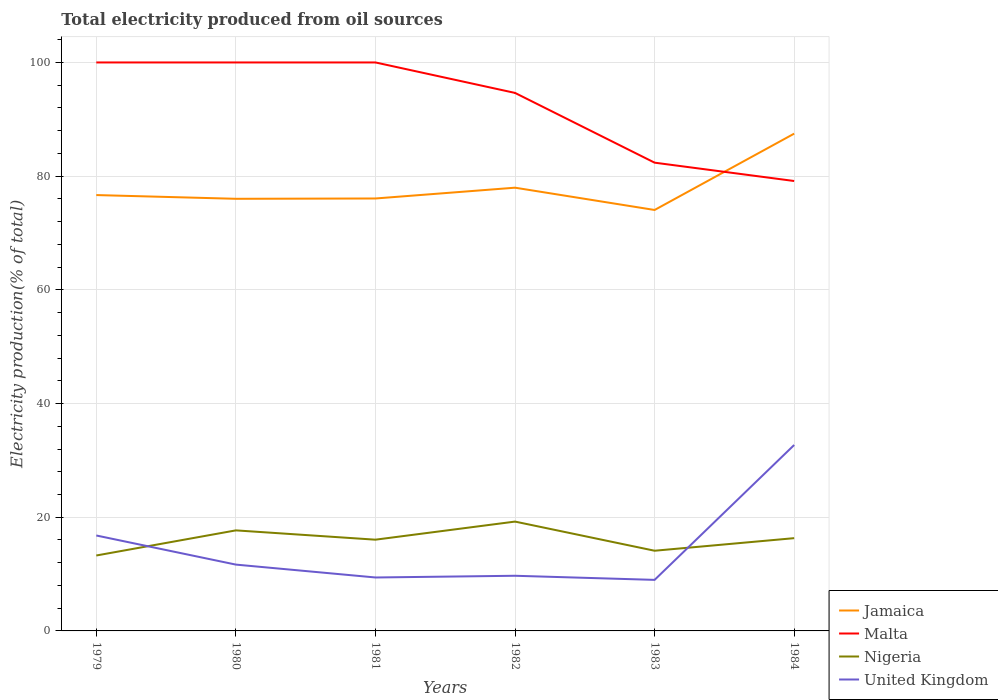Is the number of lines equal to the number of legend labels?
Your answer should be very brief. Yes. Across all years, what is the maximum total electricity produced in Nigeria?
Offer a very short reply. 13.27. In which year was the total electricity produced in United Kingdom maximum?
Give a very brief answer. 1983. What is the total total electricity produced in Nigeria in the graph?
Keep it short and to the point. -2.21. What is the difference between the highest and the second highest total electricity produced in United Kingdom?
Your answer should be compact. 23.73. What is the difference between the highest and the lowest total electricity produced in Nigeria?
Offer a terse response. 3. Is the total electricity produced in Nigeria strictly greater than the total electricity produced in Jamaica over the years?
Offer a terse response. Yes. How many lines are there?
Your answer should be very brief. 4. How many years are there in the graph?
Offer a very short reply. 6. Are the values on the major ticks of Y-axis written in scientific E-notation?
Offer a terse response. No. Does the graph contain any zero values?
Your answer should be compact. No. Where does the legend appear in the graph?
Offer a terse response. Bottom right. How are the legend labels stacked?
Offer a very short reply. Vertical. What is the title of the graph?
Offer a very short reply. Total electricity produced from oil sources. What is the label or title of the X-axis?
Your answer should be very brief. Years. What is the label or title of the Y-axis?
Make the answer very short. Electricity production(% of total). What is the Electricity production(% of total) of Jamaica in 1979?
Provide a short and direct response. 76.67. What is the Electricity production(% of total) in Nigeria in 1979?
Make the answer very short. 13.27. What is the Electricity production(% of total) in United Kingdom in 1979?
Offer a very short reply. 16.79. What is the Electricity production(% of total) in Jamaica in 1980?
Your answer should be compact. 76.01. What is the Electricity production(% of total) in Malta in 1980?
Provide a succinct answer. 100. What is the Electricity production(% of total) in Nigeria in 1980?
Give a very brief answer. 17.69. What is the Electricity production(% of total) of United Kingdom in 1980?
Keep it short and to the point. 11.67. What is the Electricity production(% of total) of Jamaica in 1981?
Offer a very short reply. 76.07. What is the Electricity production(% of total) in Nigeria in 1981?
Keep it short and to the point. 16.05. What is the Electricity production(% of total) of United Kingdom in 1981?
Provide a short and direct response. 9.4. What is the Electricity production(% of total) in Jamaica in 1982?
Give a very brief answer. 77.97. What is the Electricity production(% of total) in Malta in 1982?
Make the answer very short. 94.64. What is the Electricity production(% of total) of Nigeria in 1982?
Your answer should be very brief. 19.23. What is the Electricity production(% of total) of United Kingdom in 1982?
Provide a succinct answer. 9.7. What is the Electricity production(% of total) in Jamaica in 1983?
Your response must be concise. 74.05. What is the Electricity production(% of total) in Malta in 1983?
Keep it short and to the point. 82.37. What is the Electricity production(% of total) in Nigeria in 1983?
Offer a terse response. 14.11. What is the Electricity production(% of total) in United Kingdom in 1983?
Give a very brief answer. 8.98. What is the Electricity production(% of total) of Jamaica in 1984?
Ensure brevity in your answer.  87.48. What is the Electricity production(% of total) in Malta in 1984?
Provide a succinct answer. 79.14. What is the Electricity production(% of total) in Nigeria in 1984?
Ensure brevity in your answer.  16.32. What is the Electricity production(% of total) in United Kingdom in 1984?
Your answer should be compact. 32.71. Across all years, what is the maximum Electricity production(% of total) of Jamaica?
Your answer should be very brief. 87.48. Across all years, what is the maximum Electricity production(% of total) in Nigeria?
Provide a short and direct response. 19.23. Across all years, what is the maximum Electricity production(% of total) of United Kingdom?
Your response must be concise. 32.71. Across all years, what is the minimum Electricity production(% of total) in Jamaica?
Give a very brief answer. 74.05. Across all years, what is the minimum Electricity production(% of total) in Malta?
Offer a terse response. 79.14. Across all years, what is the minimum Electricity production(% of total) in Nigeria?
Provide a succinct answer. 13.27. Across all years, what is the minimum Electricity production(% of total) in United Kingdom?
Offer a very short reply. 8.98. What is the total Electricity production(% of total) of Jamaica in the graph?
Keep it short and to the point. 468.25. What is the total Electricity production(% of total) in Malta in the graph?
Provide a short and direct response. 556.15. What is the total Electricity production(% of total) of Nigeria in the graph?
Make the answer very short. 96.66. What is the total Electricity production(% of total) of United Kingdom in the graph?
Offer a very short reply. 89.24. What is the difference between the Electricity production(% of total) of Jamaica in 1979 and that in 1980?
Give a very brief answer. 0.66. What is the difference between the Electricity production(% of total) of Nigeria in 1979 and that in 1980?
Your answer should be compact. -4.42. What is the difference between the Electricity production(% of total) of United Kingdom in 1979 and that in 1980?
Your response must be concise. 5.12. What is the difference between the Electricity production(% of total) in Jamaica in 1979 and that in 1981?
Give a very brief answer. 0.6. What is the difference between the Electricity production(% of total) of Malta in 1979 and that in 1981?
Your answer should be compact. 0. What is the difference between the Electricity production(% of total) in Nigeria in 1979 and that in 1981?
Provide a succinct answer. -2.78. What is the difference between the Electricity production(% of total) in United Kingdom in 1979 and that in 1981?
Make the answer very short. 7.39. What is the difference between the Electricity production(% of total) of Jamaica in 1979 and that in 1982?
Offer a very short reply. -1.3. What is the difference between the Electricity production(% of total) in Malta in 1979 and that in 1982?
Make the answer very short. 5.36. What is the difference between the Electricity production(% of total) of Nigeria in 1979 and that in 1982?
Provide a short and direct response. -5.96. What is the difference between the Electricity production(% of total) of United Kingdom in 1979 and that in 1982?
Offer a terse response. 7.09. What is the difference between the Electricity production(% of total) of Jamaica in 1979 and that in 1983?
Make the answer very short. 2.62. What is the difference between the Electricity production(% of total) of Malta in 1979 and that in 1983?
Ensure brevity in your answer.  17.63. What is the difference between the Electricity production(% of total) of Nigeria in 1979 and that in 1983?
Give a very brief answer. -0.84. What is the difference between the Electricity production(% of total) in United Kingdom in 1979 and that in 1983?
Keep it short and to the point. 7.81. What is the difference between the Electricity production(% of total) in Jamaica in 1979 and that in 1984?
Your answer should be very brief. -10.8. What is the difference between the Electricity production(% of total) in Malta in 1979 and that in 1984?
Give a very brief answer. 20.86. What is the difference between the Electricity production(% of total) in Nigeria in 1979 and that in 1984?
Make the answer very short. -3.05. What is the difference between the Electricity production(% of total) in United Kingdom in 1979 and that in 1984?
Provide a succinct answer. -15.92. What is the difference between the Electricity production(% of total) of Jamaica in 1980 and that in 1981?
Keep it short and to the point. -0.05. What is the difference between the Electricity production(% of total) in Nigeria in 1980 and that in 1981?
Offer a very short reply. 1.64. What is the difference between the Electricity production(% of total) of United Kingdom in 1980 and that in 1981?
Offer a very short reply. 2.26. What is the difference between the Electricity production(% of total) in Jamaica in 1980 and that in 1982?
Your answer should be very brief. -1.96. What is the difference between the Electricity production(% of total) of Malta in 1980 and that in 1982?
Offer a terse response. 5.36. What is the difference between the Electricity production(% of total) in Nigeria in 1980 and that in 1982?
Keep it short and to the point. -1.55. What is the difference between the Electricity production(% of total) in United Kingdom in 1980 and that in 1982?
Give a very brief answer. 1.96. What is the difference between the Electricity production(% of total) in Jamaica in 1980 and that in 1983?
Keep it short and to the point. 1.97. What is the difference between the Electricity production(% of total) in Malta in 1980 and that in 1983?
Make the answer very short. 17.63. What is the difference between the Electricity production(% of total) of Nigeria in 1980 and that in 1983?
Give a very brief answer. 3.58. What is the difference between the Electricity production(% of total) in United Kingdom in 1980 and that in 1983?
Your answer should be very brief. 2.69. What is the difference between the Electricity production(% of total) in Jamaica in 1980 and that in 1984?
Offer a very short reply. -11.46. What is the difference between the Electricity production(% of total) of Malta in 1980 and that in 1984?
Ensure brevity in your answer.  20.86. What is the difference between the Electricity production(% of total) of Nigeria in 1980 and that in 1984?
Offer a very short reply. 1.37. What is the difference between the Electricity production(% of total) in United Kingdom in 1980 and that in 1984?
Provide a short and direct response. -21.04. What is the difference between the Electricity production(% of total) in Jamaica in 1981 and that in 1982?
Your answer should be compact. -1.9. What is the difference between the Electricity production(% of total) in Malta in 1981 and that in 1982?
Give a very brief answer. 5.36. What is the difference between the Electricity production(% of total) in Nigeria in 1981 and that in 1982?
Provide a succinct answer. -3.18. What is the difference between the Electricity production(% of total) in United Kingdom in 1981 and that in 1982?
Offer a very short reply. -0.3. What is the difference between the Electricity production(% of total) of Jamaica in 1981 and that in 1983?
Give a very brief answer. 2.02. What is the difference between the Electricity production(% of total) in Malta in 1981 and that in 1983?
Your response must be concise. 17.63. What is the difference between the Electricity production(% of total) in Nigeria in 1981 and that in 1983?
Your answer should be very brief. 1.94. What is the difference between the Electricity production(% of total) in United Kingdom in 1981 and that in 1983?
Keep it short and to the point. 0.42. What is the difference between the Electricity production(% of total) of Jamaica in 1981 and that in 1984?
Your answer should be very brief. -11.41. What is the difference between the Electricity production(% of total) in Malta in 1981 and that in 1984?
Provide a succinct answer. 20.86. What is the difference between the Electricity production(% of total) in Nigeria in 1981 and that in 1984?
Your answer should be compact. -0.27. What is the difference between the Electricity production(% of total) in United Kingdom in 1981 and that in 1984?
Make the answer very short. -23.31. What is the difference between the Electricity production(% of total) in Jamaica in 1982 and that in 1983?
Provide a short and direct response. 3.92. What is the difference between the Electricity production(% of total) in Malta in 1982 and that in 1983?
Keep it short and to the point. 12.27. What is the difference between the Electricity production(% of total) in Nigeria in 1982 and that in 1983?
Offer a terse response. 5.13. What is the difference between the Electricity production(% of total) of United Kingdom in 1982 and that in 1983?
Provide a short and direct response. 0.72. What is the difference between the Electricity production(% of total) in Jamaica in 1982 and that in 1984?
Your answer should be very brief. -9.51. What is the difference between the Electricity production(% of total) of Malta in 1982 and that in 1984?
Your answer should be very brief. 15.5. What is the difference between the Electricity production(% of total) of Nigeria in 1982 and that in 1984?
Give a very brief answer. 2.92. What is the difference between the Electricity production(% of total) in United Kingdom in 1982 and that in 1984?
Offer a very short reply. -23.01. What is the difference between the Electricity production(% of total) in Jamaica in 1983 and that in 1984?
Offer a terse response. -13.43. What is the difference between the Electricity production(% of total) of Malta in 1983 and that in 1984?
Provide a short and direct response. 3.23. What is the difference between the Electricity production(% of total) in Nigeria in 1983 and that in 1984?
Make the answer very short. -2.21. What is the difference between the Electricity production(% of total) of United Kingdom in 1983 and that in 1984?
Provide a succinct answer. -23.73. What is the difference between the Electricity production(% of total) of Jamaica in 1979 and the Electricity production(% of total) of Malta in 1980?
Your response must be concise. -23.33. What is the difference between the Electricity production(% of total) in Jamaica in 1979 and the Electricity production(% of total) in Nigeria in 1980?
Provide a short and direct response. 58.99. What is the difference between the Electricity production(% of total) in Jamaica in 1979 and the Electricity production(% of total) in United Kingdom in 1980?
Offer a terse response. 65.01. What is the difference between the Electricity production(% of total) of Malta in 1979 and the Electricity production(% of total) of Nigeria in 1980?
Offer a very short reply. 82.31. What is the difference between the Electricity production(% of total) in Malta in 1979 and the Electricity production(% of total) in United Kingdom in 1980?
Give a very brief answer. 88.33. What is the difference between the Electricity production(% of total) of Nigeria in 1979 and the Electricity production(% of total) of United Kingdom in 1980?
Offer a terse response. 1.6. What is the difference between the Electricity production(% of total) in Jamaica in 1979 and the Electricity production(% of total) in Malta in 1981?
Make the answer very short. -23.33. What is the difference between the Electricity production(% of total) in Jamaica in 1979 and the Electricity production(% of total) in Nigeria in 1981?
Your answer should be very brief. 60.62. What is the difference between the Electricity production(% of total) of Jamaica in 1979 and the Electricity production(% of total) of United Kingdom in 1981?
Your answer should be compact. 67.27. What is the difference between the Electricity production(% of total) of Malta in 1979 and the Electricity production(% of total) of Nigeria in 1981?
Give a very brief answer. 83.95. What is the difference between the Electricity production(% of total) of Malta in 1979 and the Electricity production(% of total) of United Kingdom in 1981?
Your answer should be very brief. 90.6. What is the difference between the Electricity production(% of total) in Nigeria in 1979 and the Electricity production(% of total) in United Kingdom in 1981?
Your answer should be very brief. 3.87. What is the difference between the Electricity production(% of total) in Jamaica in 1979 and the Electricity production(% of total) in Malta in 1982?
Ensure brevity in your answer.  -17.97. What is the difference between the Electricity production(% of total) in Jamaica in 1979 and the Electricity production(% of total) in Nigeria in 1982?
Offer a terse response. 57.44. What is the difference between the Electricity production(% of total) in Jamaica in 1979 and the Electricity production(% of total) in United Kingdom in 1982?
Offer a very short reply. 66.97. What is the difference between the Electricity production(% of total) in Malta in 1979 and the Electricity production(% of total) in Nigeria in 1982?
Offer a terse response. 80.77. What is the difference between the Electricity production(% of total) of Malta in 1979 and the Electricity production(% of total) of United Kingdom in 1982?
Your answer should be very brief. 90.3. What is the difference between the Electricity production(% of total) of Nigeria in 1979 and the Electricity production(% of total) of United Kingdom in 1982?
Make the answer very short. 3.57. What is the difference between the Electricity production(% of total) in Jamaica in 1979 and the Electricity production(% of total) in Malta in 1983?
Make the answer very short. -5.7. What is the difference between the Electricity production(% of total) of Jamaica in 1979 and the Electricity production(% of total) of Nigeria in 1983?
Provide a short and direct response. 62.57. What is the difference between the Electricity production(% of total) in Jamaica in 1979 and the Electricity production(% of total) in United Kingdom in 1983?
Your response must be concise. 67.69. What is the difference between the Electricity production(% of total) of Malta in 1979 and the Electricity production(% of total) of Nigeria in 1983?
Provide a succinct answer. 85.89. What is the difference between the Electricity production(% of total) of Malta in 1979 and the Electricity production(% of total) of United Kingdom in 1983?
Give a very brief answer. 91.02. What is the difference between the Electricity production(% of total) of Nigeria in 1979 and the Electricity production(% of total) of United Kingdom in 1983?
Give a very brief answer. 4.29. What is the difference between the Electricity production(% of total) of Jamaica in 1979 and the Electricity production(% of total) of Malta in 1984?
Offer a terse response. -2.47. What is the difference between the Electricity production(% of total) of Jamaica in 1979 and the Electricity production(% of total) of Nigeria in 1984?
Keep it short and to the point. 60.35. What is the difference between the Electricity production(% of total) of Jamaica in 1979 and the Electricity production(% of total) of United Kingdom in 1984?
Your answer should be compact. 43.96. What is the difference between the Electricity production(% of total) of Malta in 1979 and the Electricity production(% of total) of Nigeria in 1984?
Ensure brevity in your answer.  83.68. What is the difference between the Electricity production(% of total) of Malta in 1979 and the Electricity production(% of total) of United Kingdom in 1984?
Give a very brief answer. 67.29. What is the difference between the Electricity production(% of total) in Nigeria in 1979 and the Electricity production(% of total) in United Kingdom in 1984?
Your answer should be very brief. -19.44. What is the difference between the Electricity production(% of total) of Jamaica in 1980 and the Electricity production(% of total) of Malta in 1981?
Give a very brief answer. -23.99. What is the difference between the Electricity production(% of total) in Jamaica in 1980 and the Electricity production(% of total) in Nigeria in 1981?
Give a very brief answer. 59.96. What is the difference between the Electricity production(% of total) in Jamaica in 1980 and the Electricity production(% of total) in United Kingdom in 1981?
Your response must be concise. 66.61. What is the difference between the Electricity production(% of total) of Malta in 1980 and the Electricity production(% of total) of Nigeria in 1981?
Your answer should be very brief. 83.95. What is the difference between the Electricity production(% of total) in Malta in 1980 and the Electricity production(% of total) in United Kingdom in 1981?
Offer a terse response. 90.6. What is the difference between the Electricity production(% of total) in Nigeria in 1980 and the Electricity production(% of total) in United Kingdom in 1981?
Provide a succinct answer. 8.29. What is the difference between the Electricity production(% of total) in Jamaica in 1980 and the Electricity production(% of total) in Malta in 1982?
Your answer should be very brief. -18.63. What is the difference between the Electricity production(% of total) in Jamaica in 1980 and the Electricity production(% of total) in Nigeria in 1982?
Provide a succinct answer. 56.78. What is the difference between the Electricity production(% of total) of Jamaica in 1980 and the Electricity production(% of total) of United Kingdom in 1982?
Your answer should be compact. 66.31. What is the difference between the Electricity production(% of total) in Malta in 1980 and the Electricity production(% of total) in Nigeria in 1982?
Your answer should be very brief. 80.77. What is the difference between the Electricity production(% of total) in Malta in 1980 and the Electricity production(% of total) in United Kingdom in 1982?
Your response must be concise. 90.3. What is the difference between the Electricity production(% of total) of Nigeria in 1980 and the Electricity production(% of total) of United Kingdom in 1982?
Keep it short and to the point. 7.99. What is the difference between the Electricity production(% of total) in Jamaica in 1980 and the Electricity production(% of total) in Malta in 1983?
Make the answer very short. -6.36. What is the difference between the Electricity production(% of total) in Jamaica in 1980 and the Electricity production(% of total) in Nigeria in 1983?
Make the answer very short. 61.91. What is the difference between the Electricity production(% of total) of Jamaica in 1980 and the Electricity production(% of total) of United Kingdom in 1983?
Your response must be concise. 67.03. What is the difference between the Electricity production(% of total) in Malta in 1980 and the Electricity production(% of total) in Nigeria in 1983?
Keep it short and to the point. 85.89. What is the difference between the Electricity production(% of total) in Malta in 1980 and the Electricity production(% of total) in United Kingdom in 1983?
Offer a very short reply. 91.02. What is the difference between the Electricity production(% of total) in Nigeria in 1980 and the Electricity production(% of total) in United Kingdom in 1983?
Keep it short and to the point. 8.71. What is the difference between the Electricity production(% of total) of Jamaica in 1980 and the Electricity production(% of total) of Malta in 1984?
Provide a succinct answer. -3.13. What is the difference between the Electricity production(% of total) in Jamaica in 1980 and the Electricity production(% of total) in Nigeria in 1984?
Your answer should be very brief. 59.7. What is the difference between the Electricity production(% of total) in Jamaica in 1980 and the Electricity production(% of total) in United Kingdom in 1984?
Your answer should be compact. 43.31. What is the difference between the Electricity production(% of total) in Malta in 1980 and the Electricity production(% of total) in Nigeria in 1984?
Offer a very short reply. 83.68. What is the difference between the Electricity production(% of total) of Malta in 1980 and the Electricity production(% of total) of United Kingdom in 1984?
Your answer should be compact. 67.29. What is the difference between the Electricity production(% of total) of Nigeria in 1980 and the Electricity production(% of total) of United Kingdom in 1984?
Give a very brief answer. -15.02. What is the difference between the Electricity production(% of total) in Jamaica in 1981 and the Electricity production(% of total) in Malta in 1982?
Offer a terse response. -18.57. What is the difference between the Electricity production(% of total) in Jamaica in 1981 and the Electricity production(% of total) in Nigeria in 1982?
Ensure brevity in your answer.  56.84. What is the difference between the Electricity production(% of total) of Jamaica in 1981 and the Electricity production(% of total) of United Kingdom in 1982?
Ensure brevity in your answer.  66.37. What is the difference between the Electricity production(% of total) in Malta in 1981 and the Electricity production(% of total) in Nigeria in 1982?
Keep it short and to the point. 80.77. What is the difference between the Electricity production(% of total) of Malta in 1981 and the Electricity production(% of total) of United Kingdom in 1982?
Offer a terse response. 90.3. What is the difference between the Electricity production(% of total) of Nigeria in 1981 and the Electricity production(% of total) of United Kingdom in 1982?
Provide a succinct answer. 6.35. What is the difference between the Electricity production(% of total) of Jamaica in 1981 and the Electricity production(% of total) of Malta in 1983?
Offer a very short reply. -6.3. What is the difference between the Electricity production(% of total) in Jamaica in 1981 and the Electricity production(% of total) in Nigeria in 1983?
Your answer should be very brief. 61.96. What is the difference between the Electricity production(% of total) in Jamaica in 1981 and the Electricity production(% of total) in United Kingdom in 1983?
Your answer should be very brief. 67.09. What is the difference between the Electricity production(% of total) in Malta in 1981 and the Electricity production(% of total) in Nigeria in 1983?
Give a very brief answer. 85.89. What is the difference between the Electricity production(% of total) in Malta in 1981 and the Electricity production(% of total) in United Kingdom in 1983?
Your response must be concise. 91.02. What is the difference between the Electricity production(% of total) in Nigeria in 1981 and the Electricity production(% of total) in United Kingdom in 1983?
Your answer should be very brief. 7.07. What is the difference between the Electricity production(% of total) of Jamaica in 1981 and the Electricity production(% of total) of Malta in 1984?
Give a very brief answer. -3.07. What is the difference between the Electricity production(% of total) in Jamaica in 1981 and the Electricity production(% of total) in Nigeria in 1984?
Offer a terse response. 59.75. What is the difference between the Electricity production(% of total) of Jamaica in 1981 and the Electricity production(% of total) of United Kingdom in 1984?
Make the answer very short. 43.36. What is the difference between the Electricity production(% of total) in Malta in 1981 and the Electricity production(% of total) in Nigeria in 1984?
Keep it short and to the point. 83.68. What is the difference between the Electricity production(% of total) in Malta in 1981 and the Electricity production(% of total) in United Kingdom in 1984?
Keep it short and to the point. 67.29. What is the difference between the Electricity production(% of total) of Nigeria in 1981 and the Electricity production(% of total) of United Kingdom in 1984?
Your answer should be compact. -16.66. What is the difference between the Electricity production(% of total) in Jamaica in 1982 and the Electricity production(% of total) in Malta in 1983?
Provide a short and direct response. -4.4. What is the difference between the Electricity production(% of total) in Jamaica in 1982 and the Electricity production(% of total) in Nigeria in 1983?
Provide a short and direct response. 63.86. What is the difference between the Electricity production(% of total) in Jamaica in 1982 and the Electricity production(% of total) in United Kingdom in 1983?
Your response must be concise. 68.99. What is the difference between the Electricity production(% of total) of Malta in 1982 and the Electricity production(% of total) of Nigeria in 1983?
Ensure brevity in your answer.  80.53. What is the difference between the Electricity production(% of total) of Malta in 1982 and the Electricity production(% of total) of United Kingdom in 1983?
Offer a terse response. 85.66. What is the difference between the Electricity production(% of total) in Nigeria in 1982 and the Electricity production(% of total) in United Kingdom in 1983?
Offer a very short reply. 10.25. What is the difference between the Electricity production(% of total) of Jamaica in 1982 and the Electricity production(% of total) of Malta in 1984?
Keep it short and to the point. -1.17. What is the difference between the Electricity production(% of total) of Jamaica in 1982 and the Electricity production(% of total) of Nigeria in 1984?
Provide a short and direct response. 61.65. What is the difference between the Electricity production(% of total) in Jamaica in 1982 and the Electricity production(% of total) in United Kingdom in 1984?
Ensure brevity in your answer.  45.26. What is the difference between the Electricity production(% of total) of Malta in 1982 and the Electricity production(% of total) of Nigeria in 1984?
Give a very brief answer. 78.32. What is the difference between the Electricity production(% of total) in Malta in 1982 and the Electricity production(% of total) in United Kingdom in 1984?
Ensure brevity in your answer.  61.93. What is the difference between the Electricity production(% of total) of Nigeria in 1982 and the Electricity production(% of total) of United Kingdom in 1984?
Provide a short and direct response. -13.48. What is the difference between the Electricity production(% of total) in Jamaica in 1983 and the Electricity production(% of total) in Malta in 1984?
Your answer should be compact. -5.1. What is the difference between the Electricity production(% of total) in Jamaica in 1983 and the Electricity production(% of total) in Nigeria in 1984?
Your answer should be compact. 57.73. What is the difference between the Electricity production(% of total) in Jamaica in 1983 and the Electricity production(% of total) in United Kingdom in 1984?
Provide a succinct answer. 41.34. What is the difference between the Electricity production(% of total) of Malta in 1983 and the Electricity production(% of total) of Nigeria in 1984?
Provide a succinct answer. 66.05. What is the difference between the Electricity production(% of total) of Malta in 1983 and the Electricity production(% of total) of United Kingdom in 1984?
Provide a succinct answer. 49.66. What is the difference between the Electricity production(% of total) of Nigeria in 1983 and the Electricity production(% of total) of United Kingdom in 1984?
Make the answer very short. -18.6. What is the average Electricity production(% of total) in Jamaica per year?
Make the answer very short. 78.04. What is the average Electricity production(% of total) of Malta per year?
Your response must be concise. 92.69. What is the average Electricity production(% of total) in Nigeria per year?
Keep it short and to the point. 16.11. What is the average Electricity production(% of total) of United Kingdom per year?
Offer a very short reply. 14.87. In the year 1979, what is the difference between the Electricity production(% of total) of Jamaica and Electricity production(% of total) of Malta?
Your answer should be very brief. -23.33. In the year 1979, what is the difference between the Electricity production(% of total) in Jamaica and Electricity production(% of total) in Nigeria?
Provide a succinct answer. 63.4. In the year 1979, what is the difference between the Electricity production(% of total) in Jamaica and Electricity production(% of total) in United Kingdom?
Ensure brevity in your answer.  59.88. In the year 1979, what is the difference between the Electricity production(% of total) of Malta and Electricity production(% of total) of Nigeria?
Offer a terse response. 86.73. In the year 1979, what is the difference between the Electricity production(% of total) of Malta and Electricity production(% of total) of United Kingdom?
Offer a terse response. 83.21. In the year 1979, what is the difference between the Electricity production(% of total) in Nigeria and Electricity production(% of total) in United Kingdom?
Offer a terse response. -3.52. In the year 1980, what is the difference between the Electricity production(% of total) in Jamaica and Electricity production(% of total) in Malta?
Ensure brevity in your answer.  -23.99. In the year 1980, what is the difference between the Electricity production(% of total) in Jamaica and Electricity production(% of total) in Nigeria?
Your answer should be very brief. 58.33. In the year 1980, what is the difference between the Electricity production(% of total) in Jamaica and Electricity production(% of total) in United Kingdom?
Make the answer very short. 64.35. In the year 1980, what is the difference between the Electricity production(% of total) in Malta and Electricity production(% of total) in Nigeria?
Your answer should be compact. 82.31. In the year 1980, what is the difference between the Electricity production(% of total) in Malta and Electricity production(% of total) in United Kingdom?
Provide a succinct answer. 88.33. In the year 1980, what is the difference between the Electricity production(% of total) in Nigeria and Electricity production(% of total) in United Kingdom?
Your answer should be very brief. 6.02. In the year 1981, what is the difference between the Electricity production(% of total) in Jamaica and Electricity production(% of total) in Malta?
Ensure brevity in your answer.  -23.93. In the year 1981, what is the difference between the Electricity production(% of total) in Jamaica and Electricity production(% of total) in Nigeria?
Give a very brief answer. 60.02. In the year 1981, what is the difference between the Electricity production(% of total) in Jamaica and Electricity production(% of total) in United Kingdom?
Provide a short and direct response. 66.67. In the year 1981, what is the difference between the Electricity production(% of total) of Malta and Electricity production(% of total) of Nigeria?
Your answer should be compact. 83.95. In the year 1981, what is the difference between the Electricity production(% of total) of Malta and Electricity production(% of total) of United Kingdom?
Provide a short and direct response. 90.6. In the year 1981, what is the difference between the Electricity production(% of total) in Nigeria and Electricity production(% of total) in United Kingdom?
Ensure brevity in your answer.  6.65. In the year 1982, what is the difference between the Electricity production(% of total) of Jamaica and Electricity production(% of total) of Malta?
Your answer should be compact. -16.67. In the year 1982, what is the difference between the Electricity production(% of total) in Jamaica and Electricity production(% of total) in Nigeria?
Make the answer very short. 58.74. In the year 1982, what is the difference between the Electricity production(% of total) of Jamaica and Electricity production(% of total) of United Kingdom?
Provide a short and direct response. 68.27. In the year 1982, what is the difference between the Electricity production(% of total) of Malta and Electricity production(% of total) of Nigeria?
Your answer should be compact. 75.41. In the year 1982, what is the difference between the Electricity production(% of total) in Malta and Electricity production(% of total) in United Kingdom?
Provide a short and direct response. 84.94. In the year 1982, what is the difference between the Electricity production(% of total) of Nigeria and Electricity production(% of total) of United Kingdom?
Keep it short and to the point. 9.53. In the year 1983, what is the difference between the Electricity production(% of total) in Jamaica and Electricity production(% of total) in Malta?
Provide a succinct answer. -8.32. In the year 1983, what is the difference between the Electricity production(% of total) in Jamaica and Electricity production(% of total) in Nigeria?
Make the answer very short. 59.94. In the year 1983, what is the difference between the Electricity production(% of total) in Jamaica and Electricity production(% of total) in United Kingdom?
Provide a succinct answer. 65.07. In the year 1983, what is the difference between the Electricity production(% of total) in Malta and Electricity production(% of total) in Nigeria?
Offer a terse response. 68.27. In the year 1983, what is the difference between the Electricity production(% of total) in Malta and Electricity production(% of total) in United Kingdom?
Provide a short and direct response. 73.39. In the year 1983, what is the difference between the Electricity production(% of total) of Nigeria and Electricity production(% of total) of United Kingdom?
Provide a short and direct response. 5.13. In the year 1984, what is the difference between the Electricity production(% of total) of Jamaica and Electricity production(% of total) of Malta?
Ensure brevity in your answer.  8.33. In the year 1984, what is the difference between the Electricity production(% of total) in Jamaica and Electricity production(% of total) in Nigeria?
Your answer should be very brief. 71.16. In the year 1984, what is the difference between the Electricity production(% of total) in Jamaica and Electricity production(% of total) in United Kingdom?
Your answer should be compact. 54.77. In the year 1984, what is the difference between the Electricity production(% of total) in Malta and Electricity production(% of total) in Nigeria?
Provide a short and direct response. 62.83. In the year 1984, what is the difference between the Electricity production(% of total) in Malta and Electricity production(% of total) in United Kingdom?
Offer a very short reply. 46.43. In the year 1984, what is the difference between the Electricity production(% of total) of Nigeria and Electricity production(% of total) of United Kingdom?
Your answer should be very brief. -16.39. What is the ratio of the Electricity production(% of total) in Jamaica in 1979 to that in 1980?
Provide a succinct answer. 1.01. What is the ratio of the Electricity production(% of total) in Malta in 1979 to that in 1980?
Give a very brief answer. 1. What is the ratio of the Electricity production(% of total) of Nigeria in 1979 to that in 1980?
Offer a very short reply. 0.75. What is the ratio of the Electricity production(% of total) in United Kingdom in 1979 to that in 1980?
Offer a terse response. 1.44. What is the ratio of the Electricity production(% of total) in Jamaica in 1979 to that in 1981?
Your answer should be very brief. 1.01. What is the ratio of the Electricity production(% of total) of Nigeria in 1979 to that in 1981?
Keep it short and to the point. 0.83. What is the ratio of the Electricity production(% of total) of United Kingdom in 1979 to that in 1981?
Give a very brief answer. 1.79. What is the ratio of the Electricity production(% of total) of Jamaica in 1979 to that in 1982?
Offer a terse response. 0.98. What is the ratio of the Electricity production(% of total) in Malta in 1979 to that in 1982?
Make the answer very short. 1.06. What is the ratio of the Electricity production(% of total) in Nigeria in 1979 to that in 1982?
Keep it short and to the point. 0.69. What is the ratio of the Electricity production(% of total) of United Kingdom in 1979 to that in 1982?
Your answer should be compact. 1.73. What is the ratio of the Electricity production(% of total) in Jamaica in 1979 to that in 1983?
Keep it short and to the point. 1.04. What is the ratio of the Electricity production(% of total) in Malta in 1979 to that in 1983?
Make the answer very short. 1.21. What is the ratio of the Electricity production(% of total) in Nigeria in 1979 to that in 1983?
Offer a very short reply. 0.94. What is the ratio of the Electricity production(% of total) in United Kingdom in 1979 to that in 1983?
Ensure brevity in your answer.  1.87. What is the ratio of the Electricity production(% of total) in Jamaica in 1979 to that in 1984?
Your answer should be very brief. 0.88. What is the ratio of the Electricity production(% of total) in Malta in 1979 to that in 1984?
Keep it short and to the point. 1.26. What is the ratio of the Electricity production(% of total) in Nigeria in 1979 to that in 1984?
Give a very brief answer. 0.81. What is the ratio of the Electricity production(% of total) in United Kingdom in 1979 to that in 1984?
Offer a terse response. 0.51. What is the ratio of the Electricity production(% of total) in Jamaica in 1980 to that in 1981?
Provide a short and direct response. 1. What is the ratio of the Electricity production(% of total) in Malta in 1980 to that in 1981?
Make the answer very short. 1. What is the ratio of the Electricity production(% of total) in Nigeria in 1980 to that in 1981?
Your answer should be very brief. 1.1. What is the ratio of the Electricity production(% of total) of United Kingdom in 1980 to that in 1981?
Offer a very short reply. 1.24. What is the ratio of the Electricity production(% of total) in Jamaica in 1980 to that in 1982?
Keep it short and to the point. 0.97. What is the ratio of the Electricity production(% of total) of Malta in 1980 to that in 1982?
Offer a very short reply. 1.06. What is the ratio of the Electricity production(% of total) in Nigeria in 1980 to that in 1982?
Give a very brief answer. 0.92. What is the ratio of the Electricity production(% of total) in United Kingdom in 1980 to that in 1982?
Make the answer very short. 1.2. What is the ratio of the Electricity production(% of total) of Jamaica in 1980 to that in 1983?
Your answer should be very brief. 1.03. What is the ratio of the Electricity production(% of total) of Malta in 1980 to that in 1983?
Make the answer very short. 1.21. What is the ratio of the Electricity production(% of total) in Nigeria in 1980 to that in 1983?
Give a very brief answer. 1.25. What is the ratio of the Electricity production(% of total) in United Kingdom in 1980 to that in 1983?
Provide a succinct answer. 1.3. What is the ratio of the Electricity production(% of total) in Jamaica in 1980 to that in 1984?
Offer a very short reply. 0.87. What is the ratio of the Electricity production(% of total) in Malta in 1980 to that in 1984?
Ensure brevity in your answer.  1.26. What is the ratio of the Electricity production(% of total) of Nigeria in 1980 to that in 1984?
Keep it short and to the point. 1.08. What is the ratio of the Electricity production(% of total) in United Kingdom in 1980 to that in 1984?
Offer a terse response. 0.36. What is the ratio of the Electricity production(% of total) in Jamaica in 1981 to that in 1982?
Ensure brevity in your answer.  0.98. What is the ratio of the Electricity production(% of total) of Malta in 1981 to that in 1982?
Provide a short and direct response. 1.06. What is the ratio of the Electricity production(% of total) of Nigeria in 1981 to that in 1982?
Provide a short and direct response. 0.83. What is the ratio of the Electricity production(% of total) of United Kingdom in 1981 to that in 1982?
Offer a terse response. 0.97. What is the ratio of the Electricity production(% of total) of Jamaica in 1981 to that in 1983?
Offer a very short reply. 1.03. What is the ratio of the Electricity production(% of total) in Malta in 1981 to that in 1983?
Offer a terse response. 1.21. What is the ratio of the Electricity production(% of total) of Nigeria in 1981 to that in 1983?
Your answer should be very brief. 1.14. What is the ratio of the Electricity production(% of total) in United Kingdom in 1981 to that in 1983?
Make the answer very short. 1.05. What is the ratio of the Electricity production(% of total) of Jamaica in 1981 to that in 1984?
Provide a succinct answer. 0.87. What is the ratio of the Electricity production(% of total) of Malta in 1981 to that in 1984?
Give a very brief answer. 1.26. What is the ratio of the Electricity production(% of total) of Nigeria in 1981 to that in 1984?
Your answer should be compact. 0.98. What is the ratio of the Electricity production(% of total) of United Kingdom in 1981 to that in 1984?
Your answer should be compact. 0.29. What is the ratio of the Electricity production(% of total) in Jamaica in 1982 to that in 1983?
Ensure brevity in your answer.  1.05. What is the ratio of the Electricity production(% of total) of Malta in 1982 to that in 1983?
Provide a succinct answer. 1.15. What is the ratio of the Electricity production(% of total) of Nigeria in 1982 to that in 1983?
Offer a terse response. 1.36. What is the ratio of the Electricity production(% of total) in United Kingdom in 1982 to that in 1983?
Your response must be concise. 1.08. What is the ratio of the Electricity production(% of total) of Jamaica in 1982 to that in 1984?
Your response must be concise. 0.89. What is the ratio of the Electricity production(% of total) of Malta in 1982 to that in 1984?
Your answer should be compact. 1.2. What is the ratio of the Electricity production(% of total) in Nigeria in 1982 to that in 1984?
Your answer should be very brief. 1.18. What is the ratio of the Electricity production(% of total) of United Kingdom in 1982 to that in 1984?
Provide a succinct answer. 0.3. What is the ratio of the Electricity production(% of total) of Jamaica in 1983 to that in 1984?
Provide a succinct answer. 0.85. What is the ratio of the Electricity production(% of total) in Malta in 1983 to that in 1984?
Your answer should be very brief. 1.04. What is the ratio of the Electricity production(% of total) of Nigeria in 1983 to that in 1984?
Provide a succinct answer. 0.86. What is the ratio of the Electricity production(% of total) of United Kingdom in 1983 to that in 1984?
Give a very brief answer. 0.27. What is the difference between the highest and the second highest Electricity production(% of total) of Jamaica?
Give a very brief answer. 9.51. What is the difference between the highest and the second highest Electricity production(% of total) of Nigeria?
Give a very brief answer. 1.55. What is the difference between the highest and the second highest Electricity production(% of total) in United Kingdom?
Provide a short and direct response. 15.92. What is the difference between the highest and the lowest Electricity production(% of total) in Jamaica?
Offer a terse response. 13.43. What is the difference between the highest and the lowest Electricity production(% of total) of Malta?
Ensure brevity in your answer.  20.86. What is the difference between the highest and the lowest Electricity production(% of total) in Nigeria?
Offer a terse response. 5.96. What is the difference between the highest and the lowest Electricity production(% of total) of United Kingdom?
Provide a short and direct response. 23.73. 